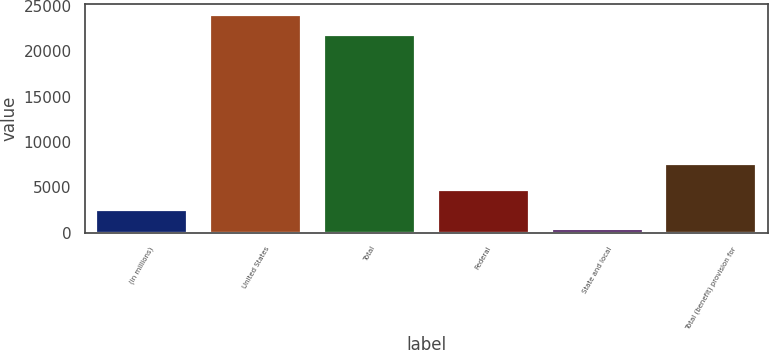<chart> <loc_0><loc_0><loc_500><loc_500><bar_chart><fcel>(in millions)<fcel>United States<fcel>Total<fcel>Federal<fcel>State and local<fcel>Total (benefit) provision for<nl><fcel>2537.7<fcel>23999.7<fcel>21852<fcel>4685.4<fcel>390<fcel>7608<nl></chart> 